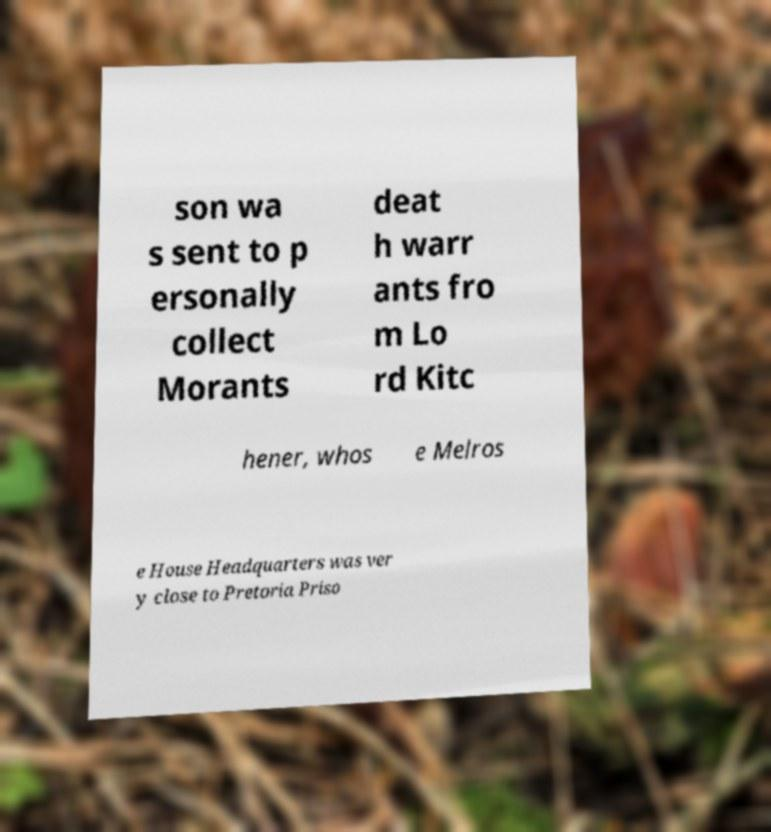For documentation purposes, I need the text within this image transcribed. Could you provide that? son wa s sent to p ersonally collect Morants deat h warr ants fro m Lo rd Kitc hener, whos e Melros e House Headquarters was ver y close to Pretoria Priso 